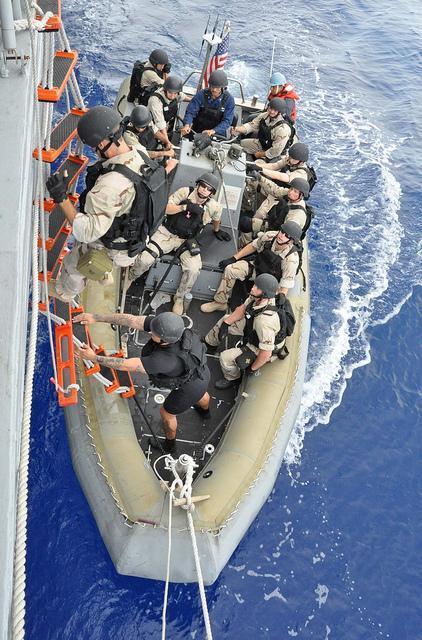How many people are there?
Give a very brief answer. 7. How many boats are there?
Give a very brief answer. 2. How many water bottles are there?
Give a very brief answer. 0. 